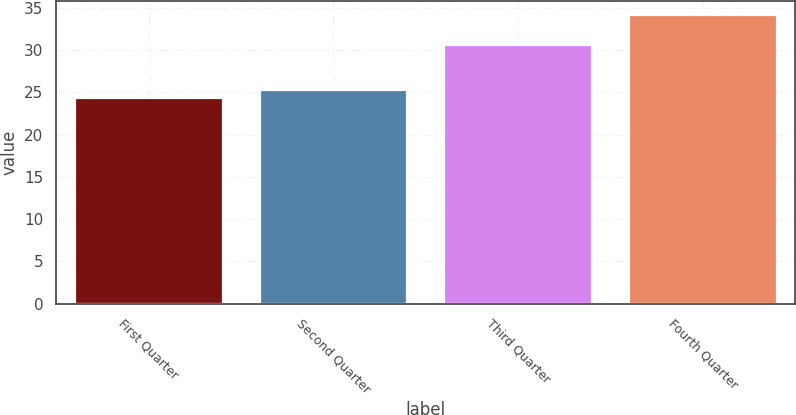Convert chart to OTSL. <chart><loc_0><loc_0><loc_500><loc_500><bar_chart><fcel>First Quarter<fcel>Second Quarter<fcel>Third Quarter<fcel>Fourth Quarter<nl><fcel>24.28<fcel>25.27<fcel>30.57<fcel>34.13<nl></chart> 